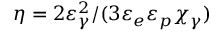Convert formula to latex. <formula><loc_0><loc_0><loc_500><loc_500>\eta = 2 \varepsilon _ { \gamma } ^ { 2 } / ( 3 \varepsilon _ { e } \varepsilon _ { p } \chi _ { \gamma } )</formula> 